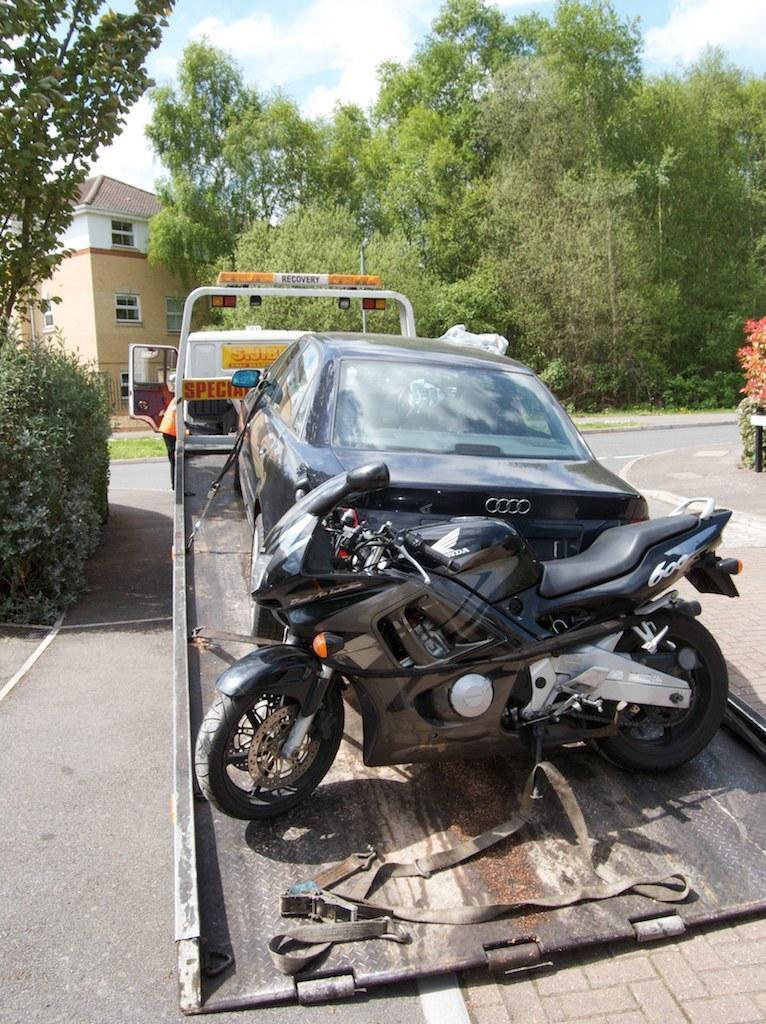Please provide a concise description of this image. In the image there is a truck carrying a bike and a car on the road, in the back there is a building on the left side with trees in front of it. 